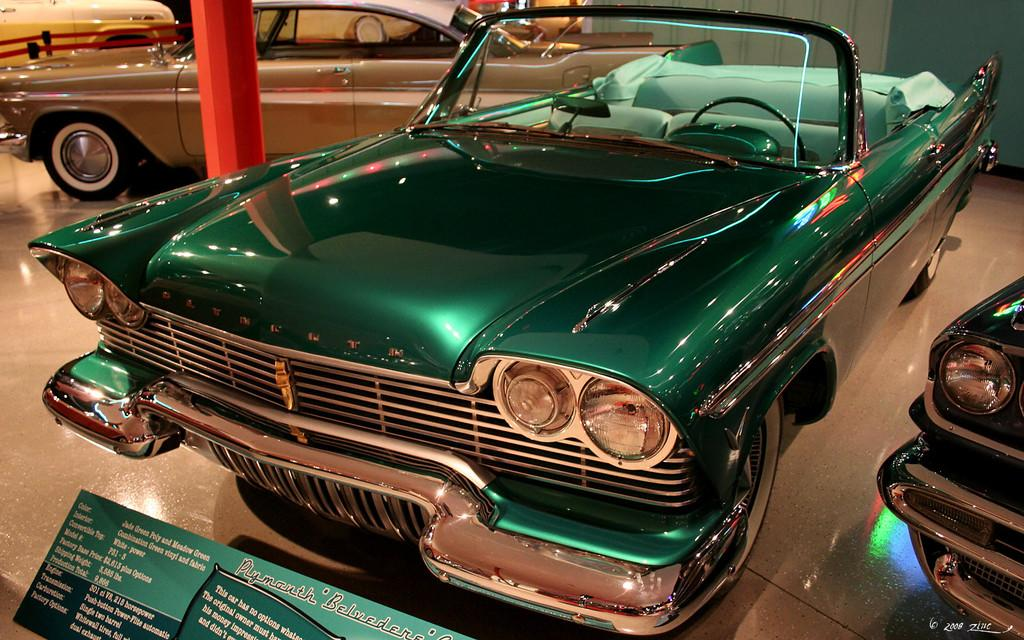What types of objects are present in the image? There are vehicles in the image. Where are the vehicles located? The vehicles are in a room. What else can be seen in the room besides the vehicles? There is a board with text in the image. How far can the vehicles travel in the image? The vehicles' range cannot be determined from the image, as it only shows them in a room and does not provide any information about their capabilities or the environment outside the room. 